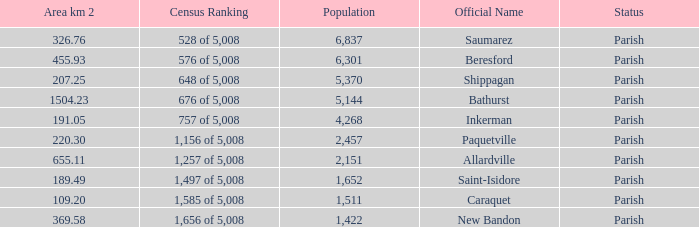What is the Area of the Saint-Isidore Parish with a Population smaller than 4,268? 189.49. 